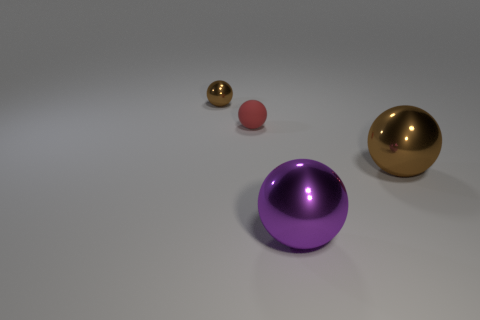Subtract all green cubes. How many brown spheres are left? 2 Subtract all red spheres. How many spheres are left? 3 Subtract all large purple metallic balls. How many balls are left? 3 Subtract all yellow balls. Subtract all purple cubes. How many balls are left? 4 Add 2 tiny red rubber things. How many objects exist? 6 Subtract 0 yellow cylinders. How many objects are left? 4 Subtract all small shiny objects. Subtract all large purple rubber cubes. How many objects are left? 3 Add 3 red objects. How many red objects are left? 4 Add 2 big brown metallic balls. How many big brown metallic balls exist? 3 